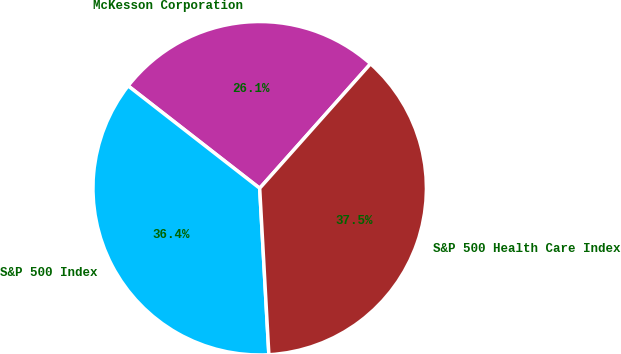Convert chart. <chart><loc_0><loc_0><loc_500><loc_500><pie_chart><fcel>McKesson Corporation<fcel>S&P 500 Index<fcel>S&P 500 Health Care Index<nl><fcel>26.05%<fcel>36.4%<fcel>37.54%<nl></chart> 